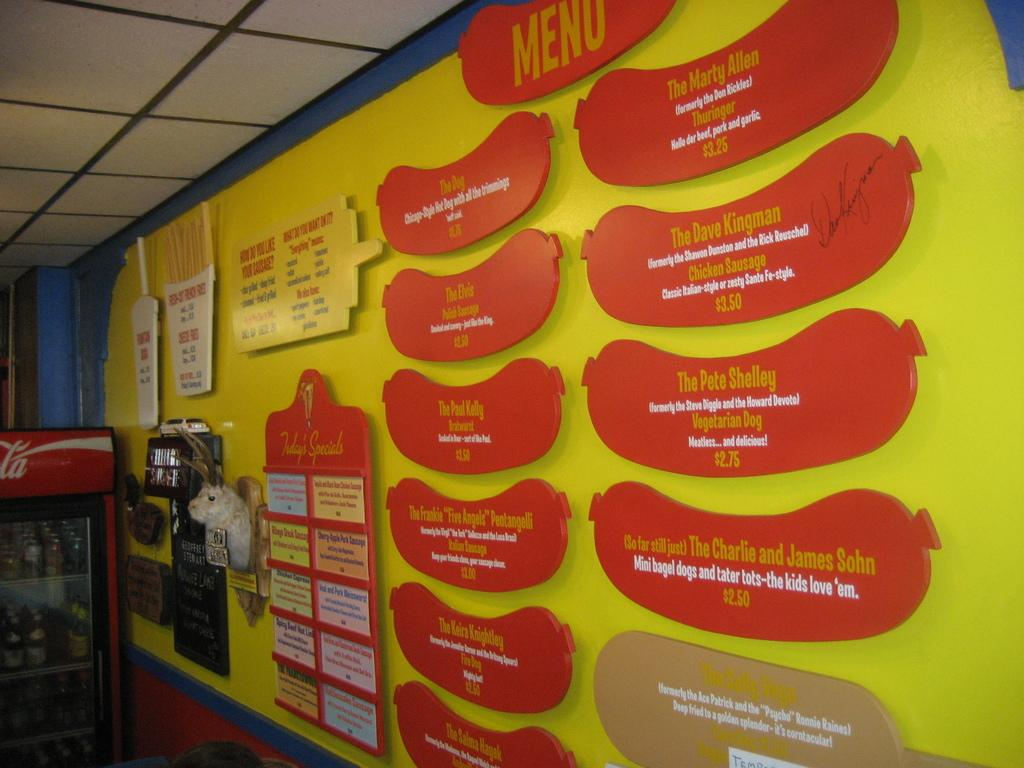<image>
Share a concise interpretation of the image provided. a wall that is yellow with red sausages that say one says the Pete Shelly vegetarian dog 2.75 